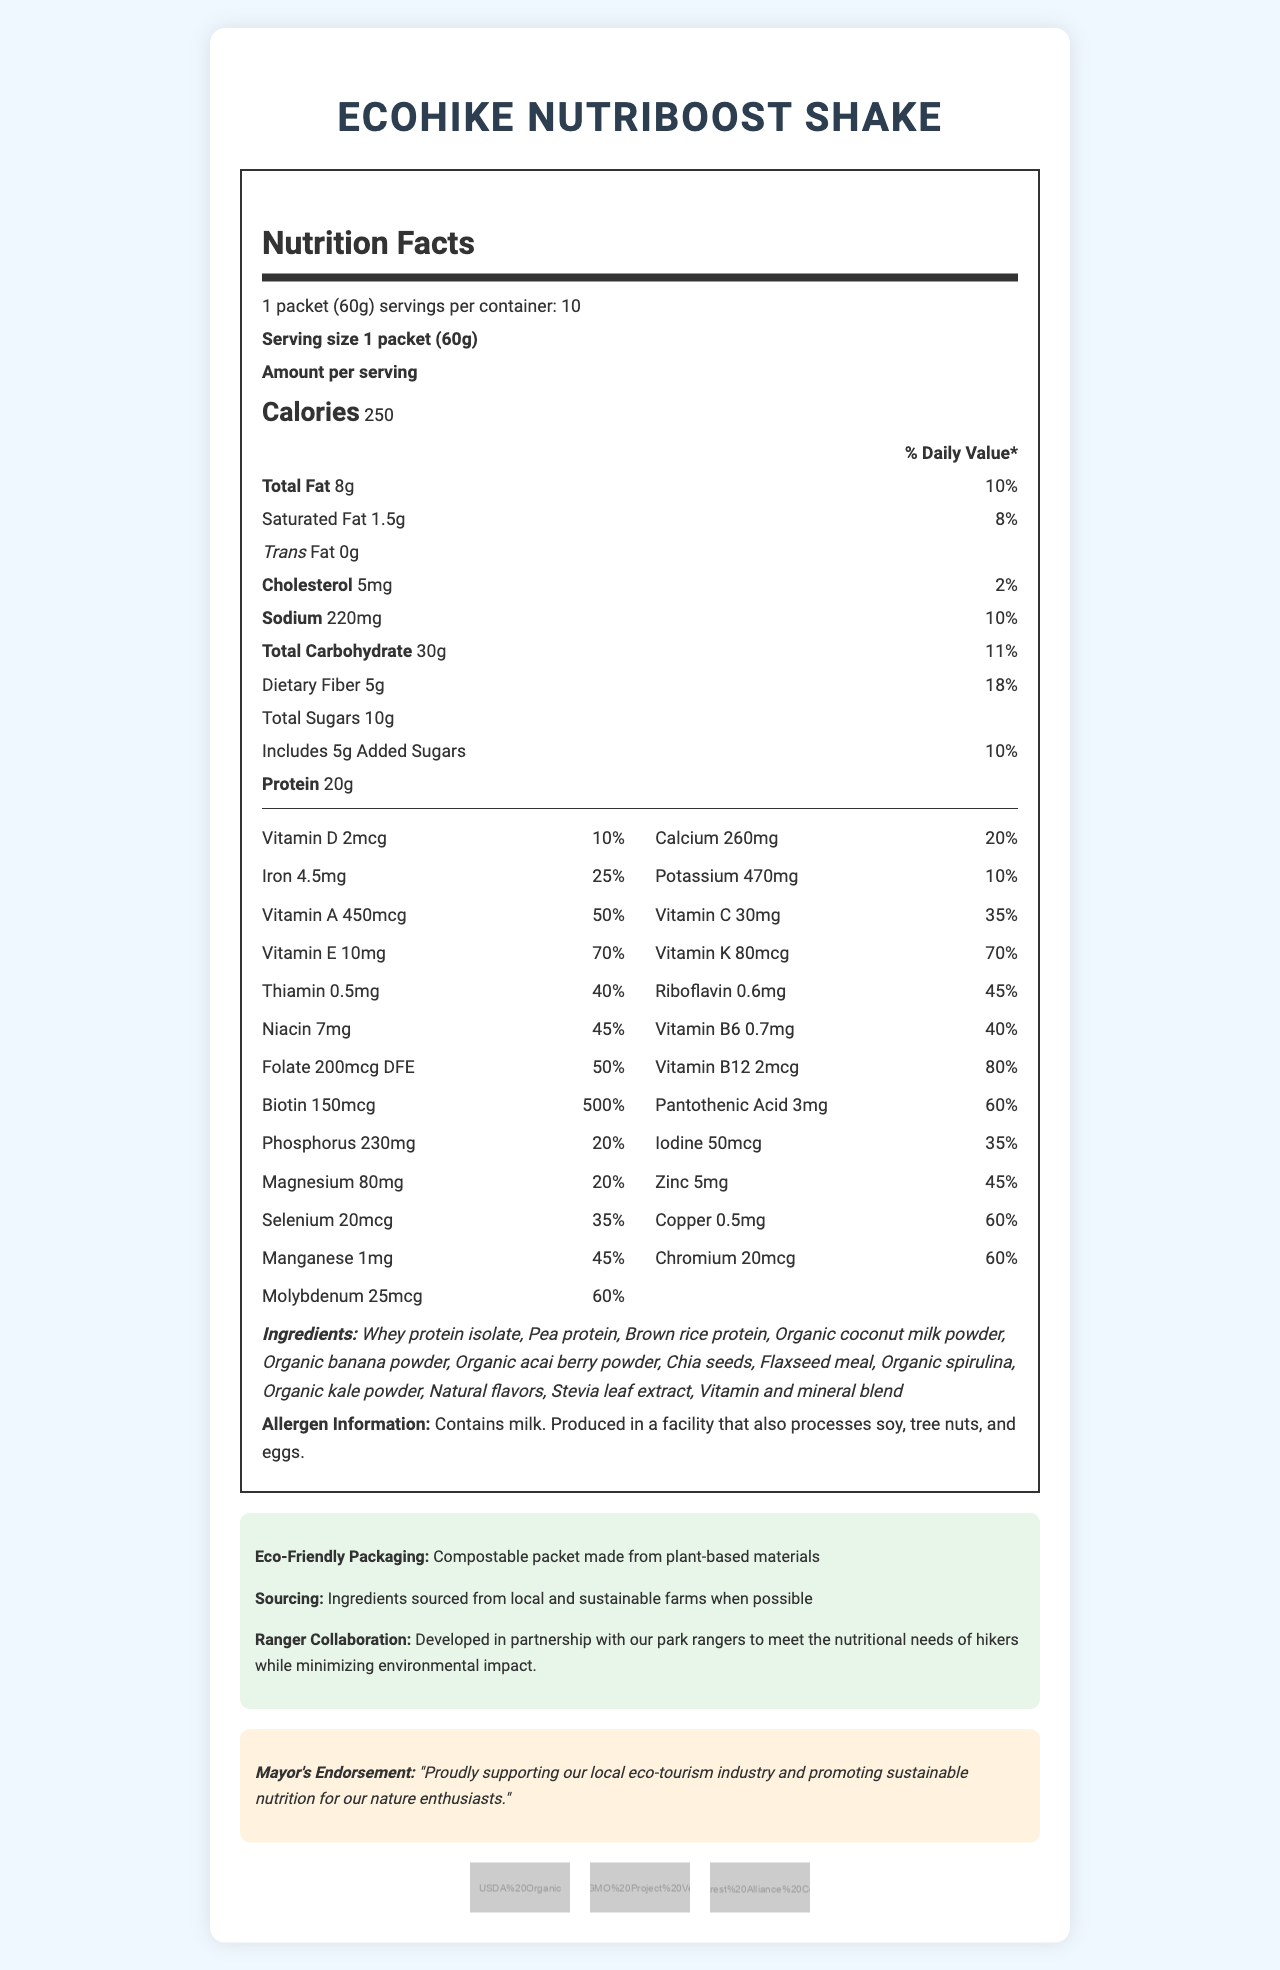what is the serving size of the EcoHike Nutriboost Shake? The serving size is clearly stated as "1 packet (60g)" in the Nutrition Facts section.
Answer: 1 packet (60g) how many servings per container are provided? The document specifies that the number of servings per container is 10.
Answer: 10 how many calories are there per serving? The label indicates that each serving contains 250 calories.
Answer: 250 what percentage of the daily value of dietary fiber does one serving provide? Dietary fiber per serving is listed as providing 18% of the daily value.
Answer: 18% is the product free from trans fat? The document states that trans fat amounts to "0g".
Answer: Yes how much protein does one serving contain? The label mentions that each serving contains 20g of protein.
Answer: 20g what certifications does the EcoHike Nutriboost Shake have? A. USDA Organic B. Rainforest Alliance Certified C. Non-GMO Project Verified D. All of the above The product is certified as USDA Organic, Rainforest Alliance Certified, and Non-GMO Project Verified, as stated in the certifications section.
Answer: D how much Vitamin B12 is in one serving? A. 1mcg B. 2mcg C. 5mcg D. 10mcg The nutrition facts include Vitamin B12 at 2mcg per serving.
Answer: B does the product contain any allergens? The allergen information states that the product contains milk and is produced in a facility that also processes soy, tree nuts, and eggs.
Answer: Yes is the packaging eco-friendly? The packaging is described as compostable and made from plant-based materials.
Answer: Yes identify two ingredients used in the shake. Two of the ingredients listed include whey protein isolate and pea protein.
Answer: Whey protein isolate, Pea protein where are the ingredients sourced from? According to the document, ingredients are sourced from local and sustainable farms when possible.
Answer: Local and sustainable farms when possible list the vitamins that are present in significant amounts (above 50% DV) in one serving. The vitamins listed in significant amounts include Vitamin A, Vitamin E, Vitamin K, Vitamin B12, and Biotin, all with daily values above 50%.
Answer: Vitamin A (50%), Vitamin E (70%), Vitamin K (70%), Vitamin B12 (80%), Biotin (500%) does the shake contain any cholesterol? There is 5mg of cholesterol per serving, which is 2% of the daily value.
Answer: Yes what is the main idea of the document? The document outlines the nutritional facts, ingredient list, allergen information, eco-friendly aspects, and certifications of the EcoHike Nutriboost Shake.
Answer: The document provides detailed nutritional information for the EcoHike Nutriboost Shake, indicating that it is a meal replacement shake designed for eco-tourists. The shake is nutrient-rich, contains eco-friendly and sustainably sourced ingredients, and has various health certifications. how much added sugar is in one serving? The label indicates that each serving includes 5g of added sugars.
Answer: 5g what is the total amount of carbohydrates in one serving? The total carbohydrate content per serving is listed as 30g.
Answer: 30g detail the mayor's endorsement mentioned in the document. The endorsement highlights support for the local eco-tourism industry and promotes the nutritional benefits of the shake.
Answer: Proudly supporting our local eco-tourism industry and promoting sustainable nutrition for our nature enthusiasts. are there any artificial sweeteners in the shake? The document only mentions stevia leaf extract as a natural sweetener, but it does not specifically state whether there are or aren't any artificial sweeteners.
Answer: Not enough information what is the primary target audience for this product as inferred from the document? The product is designed for eco-tourists as mentioned in the context and objectives of the meal replacement shake.
Answer: Eco-tourists embarking on guided nature hikes 